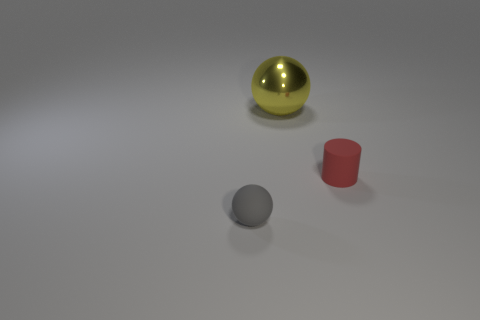Are the red object and the large yellow sphere made of the same material?
Ensure brevity in your answer.  No. The tiny object that is made of the same material as the tiny gray ball is what color?
Provide a short and direct response. Red. There is a thing that is behind the red rubber cylinder; what is its material?
Your response must be concise. Metal. There is a red object that is the same size as the gray rubber sphere; what shape is it?
Offer a very short reply. Cylinder. The rubber object that is in front of the red matte thing is what color?
Ensure brevity in your answer.  Gray. There is a tiny rubber thing in front of the red thing; are there any objects that are behind it?
Ensure brevity in your answer.  Yes. There is a sphere that is right of the sphere that is in front of the tiny cylinder; what is it made of?
Make the answer very short. Metal. Are there an equal number of red rubber things in front of the red rubber object and small red objects left of the large yellow thing?
Offer a terse response. Yes. There is a thing that is left of the matte cylinder and to the right of the rubber ball; what is its material?
Provide a short and direct response. Metal. There is a rubber object that is right of the tiny rubber thing to the left of the rubber object behind the small matte ball; what is its size?
Provide a succinct answer. Small. 